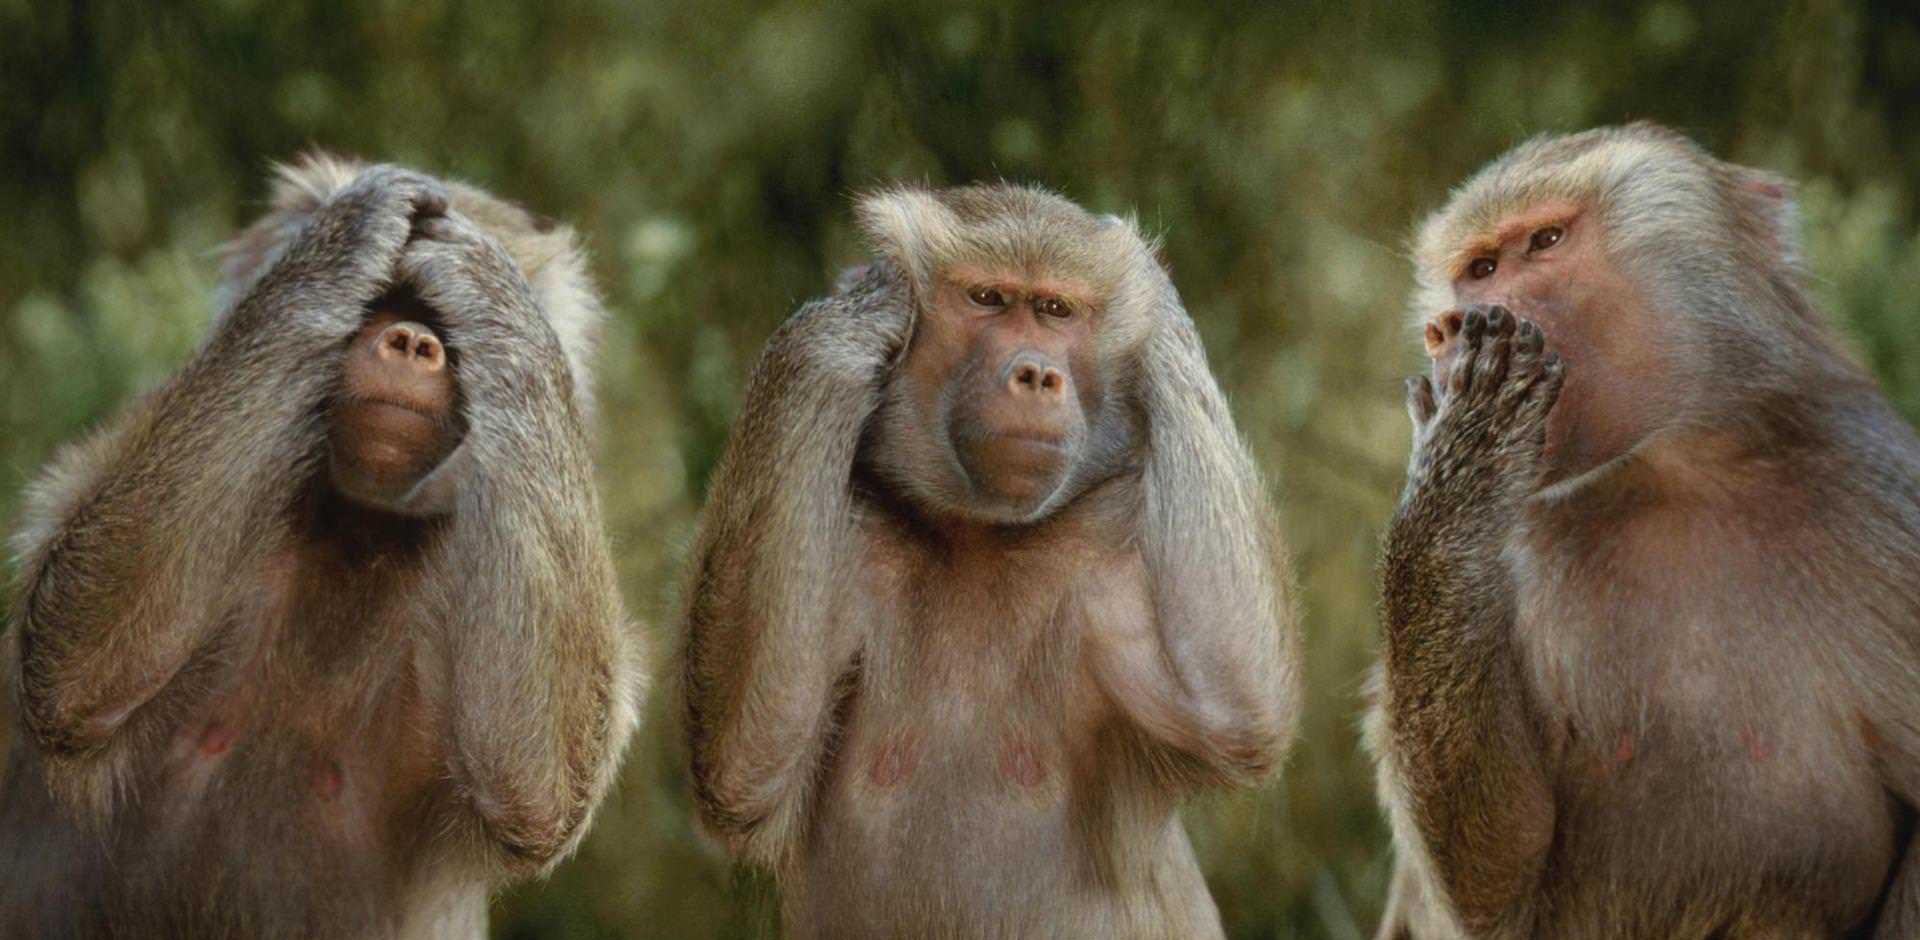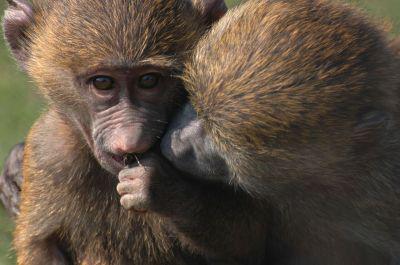The first image is the image on the left, the second image is the image on the right. For the images shown, is this caption "An image includes a baboon baring its fangs with wide-opened mouth." true? Answer yes or no. No. The first image is the image on the left, the second image is the image on the right. Assess this claim about the two images: "At least one monkey has its mouth wide open with sharp teeth visible.". Correct or not? Answer yes or no. No. 